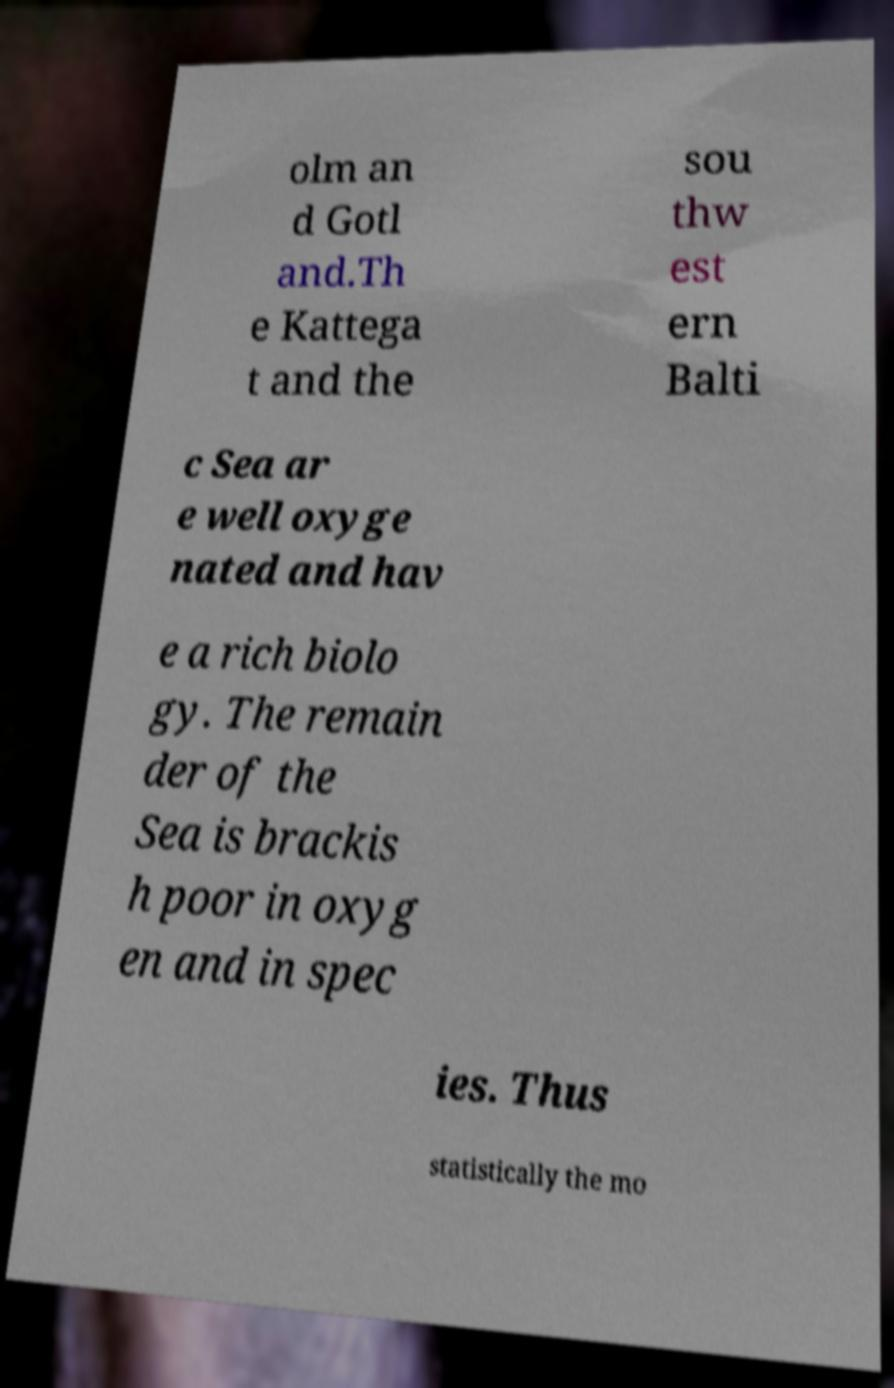Can you accurately transcribe the text from the provided image for me? olm an d Gotl and.Th e Kattega t and the sou thw est ern Balti c Sea ar e well oxyge nated and hav e a rich biolo gy. The remain der of the Sea is brackis h poor in oxyg en and in spec ies. Thus statistically the mo 